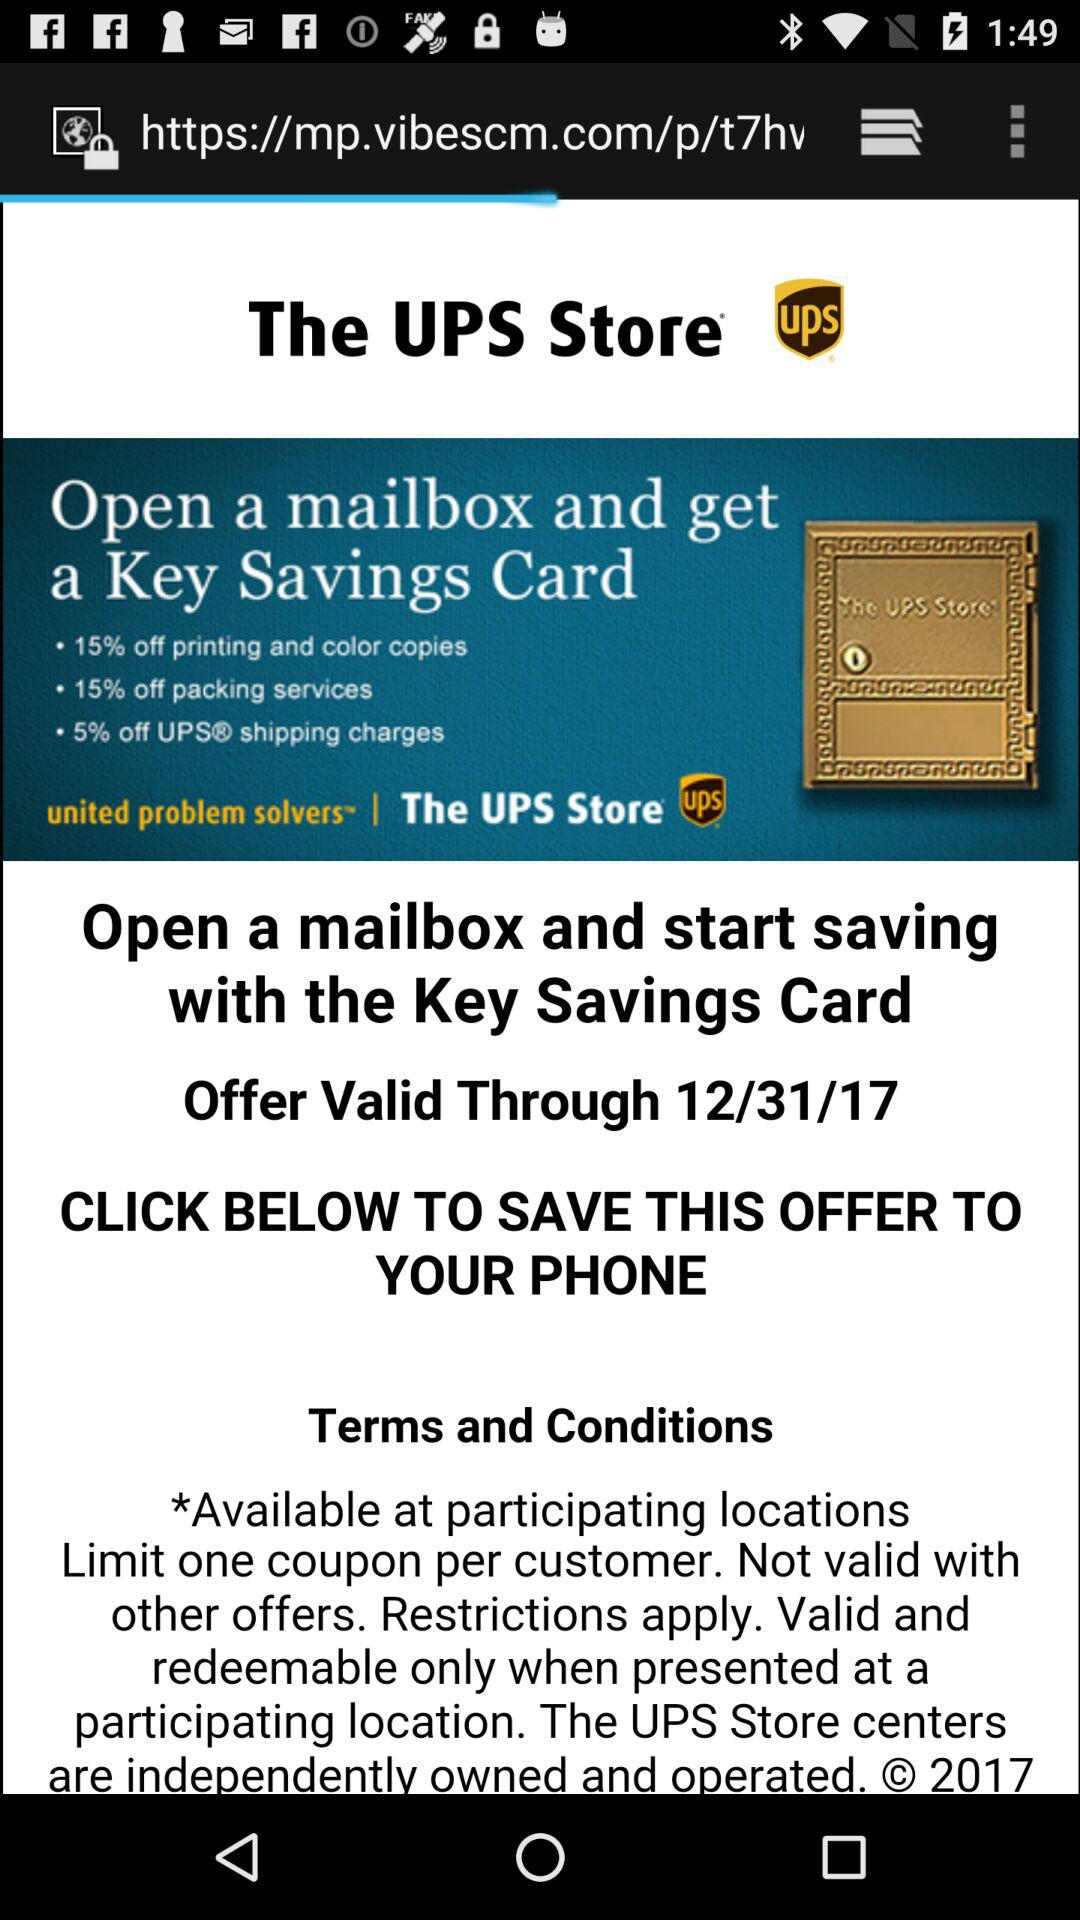Till what date is the offer valid? The offer is valid till December 31, 2017. 